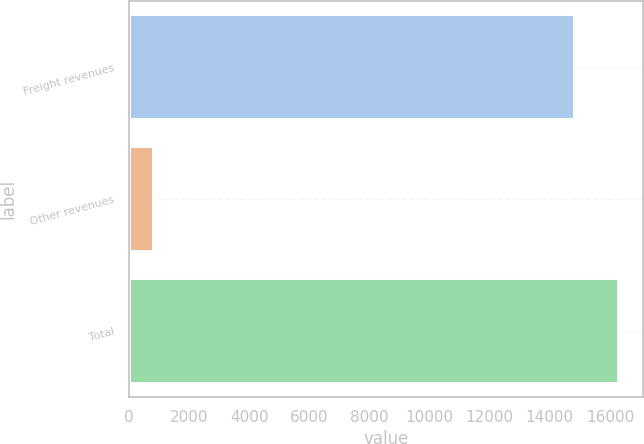Convert chart. <chart><loc_0><loc_0><loc_500><loc_500><bar_chart><fcel>Freight revenues<fcel>Other revenues<fcel>Total<nl><fcel>14791<fcel>787<fcel>16270.1<nl></chart> 